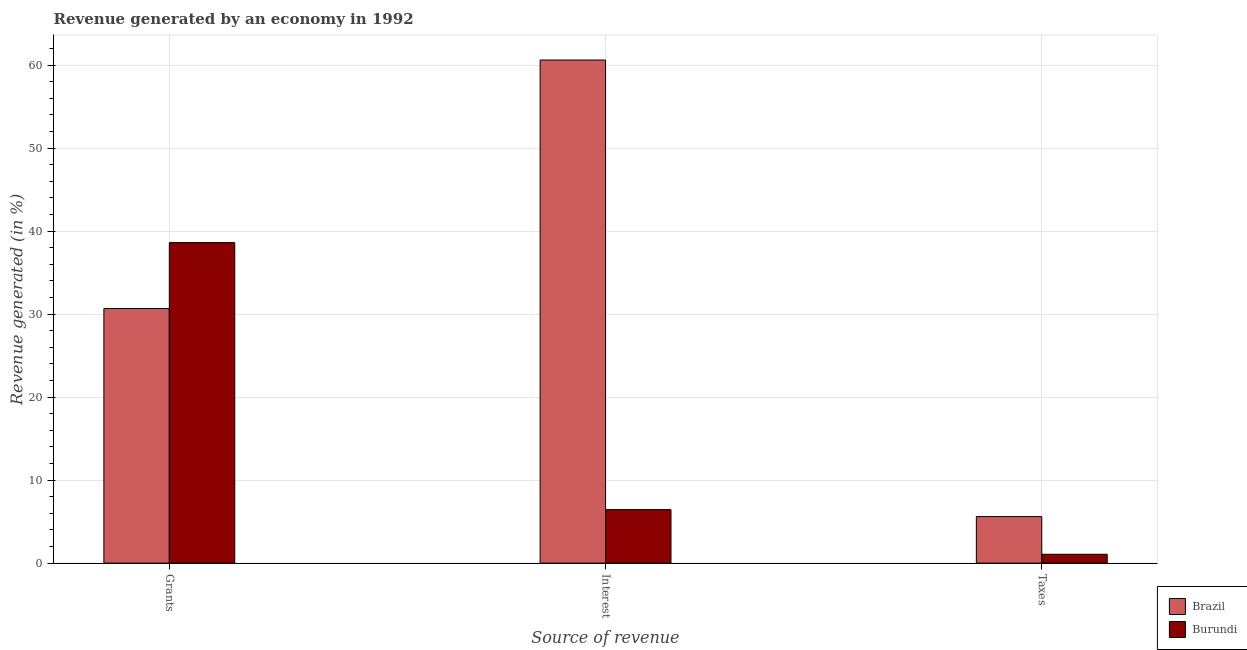How many different coloured bars are there?
Your answer should be very brief. 2. Are the number of bars per tick equal to the number of legend labels?
Your answer should be compact. Yes. Are the number of bars on each tick of the X-axis equal?
Offer a very short reply. Yes. What is the label of the 2nd group of bars from the left?
Ensure brevity in your answer.  Interest. What is the percentage of revenue generated by taxes in Brazil?
Keep it short and to the point. 5.61. Across all countries, what is the maximum percentage of revenue generated by grants?
Keep it short and to the point. 38.61. Across all countries, what is the minimum percentage of revenue generated by taxes?
Provide a succinct answer. 1.06. What is the total percentage of revenue generated by interest in the graph?
Provide a short and direct response. 67.06. What is the difference between the percentage of revenue generated by grants in Brazil and that in Burundi?
Offer a very short reply. -7.94. What is the difference between the percentage of revenue generated by taxes in Brazil and the percentage of revenue generated by interest in Burundi?
Offer a very short reply. -0.84. What is the average percentage of revenue generated by interest per country?
Your response must be concise. 33.53. What is the difference between the percentage of revenue generated by taxes and percentage of revenue generated by grants in Brazil?
Keep it short and to the point. -25.06. What is the ratio of the percentage of revenue generated by grants in Brazil to that in Burundi?
Provide a succinct answer. 0.79. What is the difference between the highest and the second highest percentage of revenue generated by interest?
Offer a very short reply. 54.16. What is the difference between the highest and the lowest percentage of revenue generated by interest?
Offer a terse response. 54.16. Is the sum of the percentage of revenue generated by interest in Brazil and Burundi greater than the maximum percentage of revenue generated by taxes across all countries?
Your answer should be very brief. Yes. What does the 1st bar from the right in Grants represents?
Your answer should be very brief. Burundi. How many bars are there?
Keep it short and to the point. 6. How many countries are there in the graph?
Make the answer very short. 2. What is the difference between two consecutive major ticks on the Y-axis?
Provide a succinct answer. 10. Does the graph contain grids?
Provide a short and direct response. Yes. How are the legend labels stacked?
Make the answer very short. Vertical. What is the title of the graph?
Keep it short and to the point. Revenue generated by an economy in 1992. Does "Namibia" appear as one of the legend labels in the graph?
Make the answer very short. No. What is the label or title of the X-axis?
Provide a short and direct response. Source of revenue. What is the label or title of the Y-axis?
Ensure brevity in your answer.  Revenue generated (in %). What is the Revenue generated (in %) of Brazil in Grants?
Offer a very short reply. 30.67. What is the Revenue generated (in %) in Burundi in Grants?
Give a very brief answer. 38.61. What is the Revenue generated (in %) in Brazil in Interest?
Ensure brevity in your answer.  60.61. What is the Revenue generated (in %) of Burundi in Interest?
Your response must be concise. 6.45. What is the Revenue generated (in %) in Brazil in Taxes?
Your response must be concise. 5.61. What is the Revenue generated (in %) in Burundi in Taxes?
Give a very brief answer. 1.06. Across all Source of revenue, what is the maximum Revenue generated (in %) in Brazil?
Provide a short and direct response. 60.61. Across all Source of revenue, what is the maximum Revenue generated (in %) of Burundi?
Ensure brevity in your answer.  38.61. Across all Source of revenue, what is the minimum Revenue generated (in %) in Brazil?
Ensure brevity in your answer.  5.61. Across all Source of revenue, what is the minimum Revenue generated (in %) of Burundi?
Make the answer very short. 1.06. What is the total Revenue generated (in %) in Brazil in the graph?
Your response must be concise. 96.89. What is the total Revenue generated (in %) in Burundi in the graph?
Your response must be concise. 46.13. What is the difference between the Revenue generated (in %) of Brazil in Grants and that in Interest?
Your answer should be very brief. -29.94. What is the difference between the Revenue generated (in %) in Burundi in Grants and that in Interest?
Your response must be concise. 32.17. What is the difference between the Revenue generated (in %) in Brazil in Grants and that in Taxes?
Your response must be concise. 25.06. What is the difference between the Revenue generated (in %) of Burundi in Grants and that in Taxes?
Your answer should be compact. 37.55. What is the difference between the Revenue generated (in %) in Brazil in Interest and that in Taxes?
Keep it short and to the point. 55. What is the difference between the Revenue generated (in %) of Burundi in Interest and that in Taxes?
Give a very brief answer. 5.38. What is the difference between the Revenue generated (in %) in Brazil in Grants and the Revenue generated (in %) in Burundi in Interest?
Provide a short and direct response. 24.22. What is the difference between the Revenue generated (in %) in Brazil in Grants and the Revenue generated (in %) in Burundi in Taxes?
Provide a succinct answer. 29.61. What is the difference between the Revenue generated (in %) of Brazil in Interest and the Revenue generated (in %) of Burundi in Taxes?
Offer a very short reply. 59.55. What is the average Revenue generated (in %) in Brazil per Source of revenue?
Make the answer very short. 32.3. What is the average Revenue generated (in %) in Burundi per Source of revenue?
Give a very brief answer. 15.38. What is the difference between the Revenue generated (in %) in Brazil and Revenue generated (in %) in Burundi in Grants?
Provide a succinct answer. -7.94. What is the difference between the Revenue generated (in %) in Brazil and Revenue generated (in %) in Burundi in Interest?
Your response must be concise. 54.16. What is the difference between the Revenue generated (in %) in Brazil and Revenue generated (in %) in Burundi in Taxes?
Your answer should be very brief. 4.54. What is the ratio of the Revenue generated (in %) in Brazil in Grants to that in Interest?
Keep it short and to the point. 0.51. What is the ratio of the Revenue generated (in %) of Burundi in Grants to that in Interest?
Your answer should be very brief. 5.99. What is the ratio of the Revenue generated (in %) in Brazil in Grants to that in Taxes?
Your response must be concise. 5.47. What is the ratio of the Revenue generated (in %) in Burundi in Grants to that in Taxes?
Provide a succinct answer. 36.28. What is the ratio of the Revenue generated (in %) of Brazil in Interest to that in Taxes?
Your answer should be very brief. 10.81. What is the ratio of the Revenue generated (in %) in Burundi in Interest to that in Taxes?
Keep it short and to the point. 6.06. What is the difference between the highest and the second highest Revenue generated (in %) in Brazil?
Ensure brevity in your answer.  29.94. What is the difference between the highest and the second highest Revenue generated (in %) of Burundi?
Provide a succinct answer. 32.17. What is the difference between the highest and the lowest Revenue generated (in %) in Brazil?
Provide a short and direct response. 55. What is the difference between the highest and the lowest Revenue generated (in %) in Burundi?
Your answer should be very brief. 37.55. 